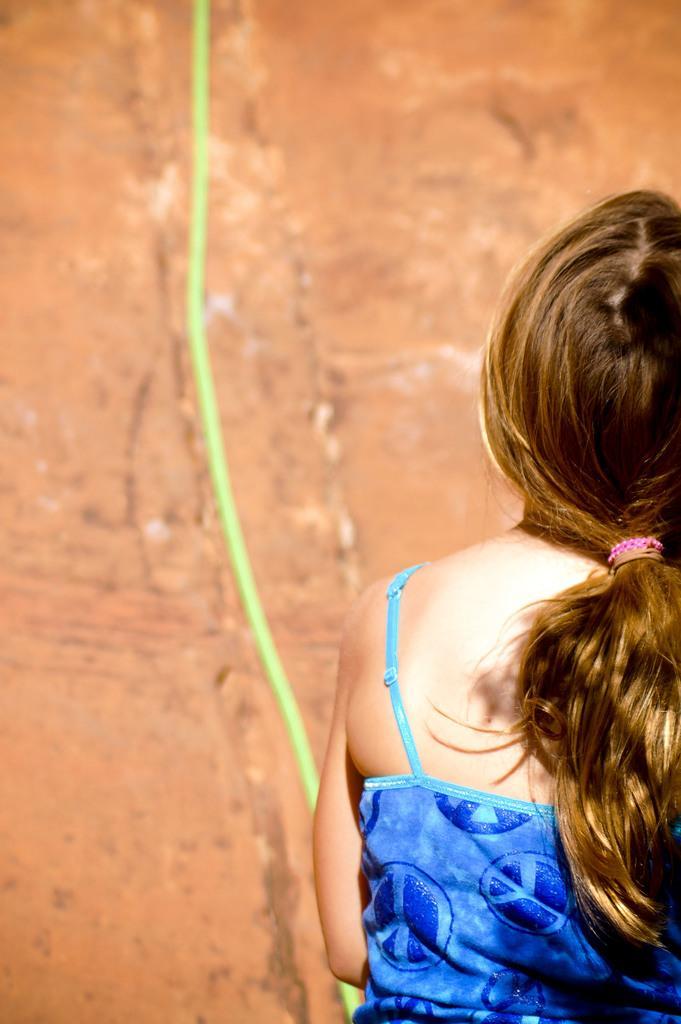In one or two sentences, can you explain what this image depicts? In this image in the front there is a girl. In the background there is an object which is green in colour. 